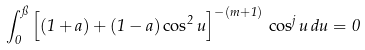<formula> <loc_0><loc_0><loc_500><loc_500>\int _ { 0 } ^ { \pi } \left [ ( 1 + a ) + ( 1 - a ) \cos ^ { 2 } u \right ] ^ { - ( m + 1 ) } \, \cos ^ { j } u \, d u = 0</formula> 